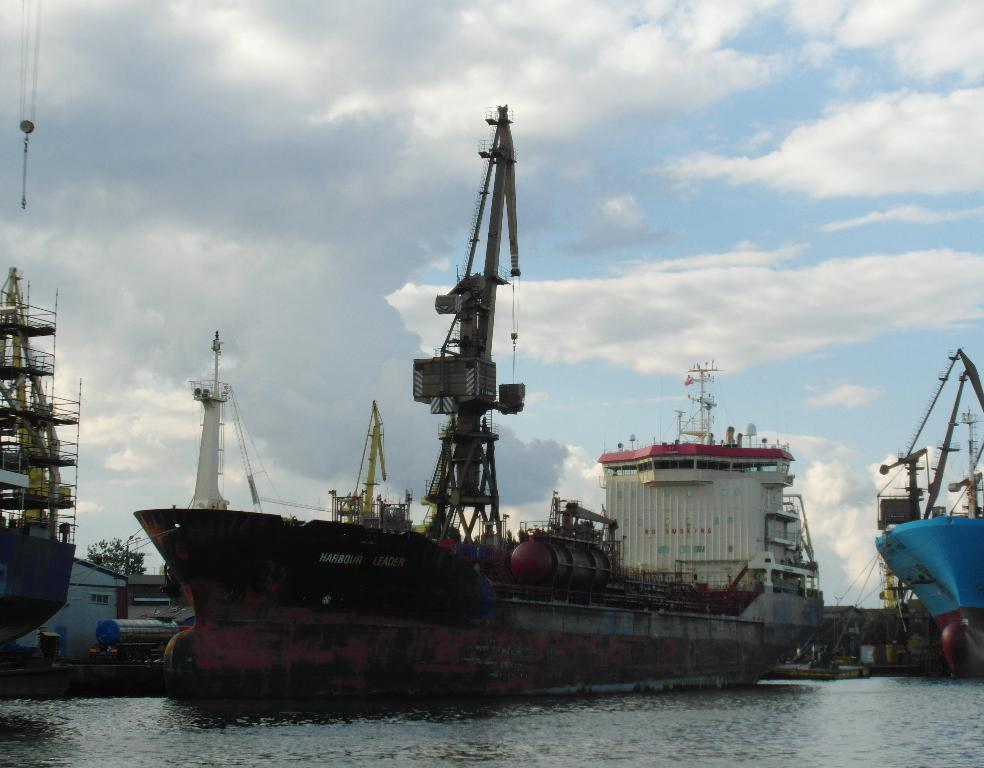What is on the water surface in the image? There are ships on the water surface in the image. What type of structures can be seen in the image? There are houses and buildings visible in the image. What else is present in the image besides the ships and structures? Containers are present in the image. What type of plantation can be seen in the image? There is no plantation present in the image. How many minutes does it take for the ships to move across the water surface in the image? The image is a still representation and does not show the ships moving, so it is impossible to determine how many minutes it would take for them to move across the water surface. 